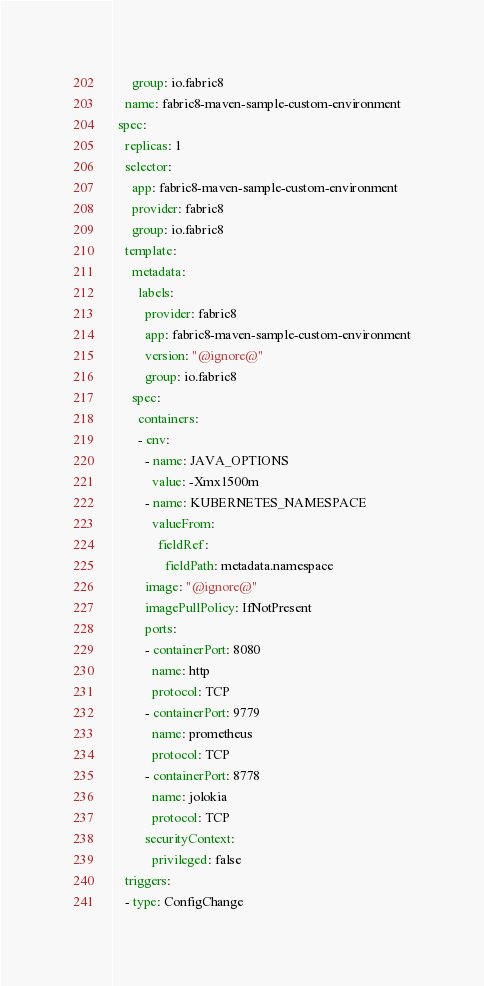Convert code to text. <code><loc_0><loc_0><loc_500><loc_500><_YAML_>      group: io.fabric8
    name: fabric8-maven-sample-custom-environment
  spec:
    replicas: 1
    selector:
      app: fabric8-maven-sample-custom-environment
      provider: fabric8
      group: io.fabric8
    template:
      metadata:
        labels:
          provider: fabric8
          app: fabric8-maven-sample-custom-environment
          version: "@ignore@"
          group: io.fabric8
      spec:
        containers:
        - env:
          - name: JAVA_OPTIONS
            value: -Xmx1500m
          - name: KUBERNETES_NAMESPACE
            valueFrom:
              fieldRef:
                fieldPath: metadata.namespace
          image: "@ignore@"
          imagePullPolicy: IfNotPresent
          ports:
          - containerPort: 8080
            name: http
            protocol: TCP
          - containerPort: 9779
            name: prometheus
            protocol: TCP
          - containerPort: 8778
            name: jolokia
            protocol: TCP
          securityContext:
            privileged: false
    triggers:
    - type: ConfigChange
</code> 